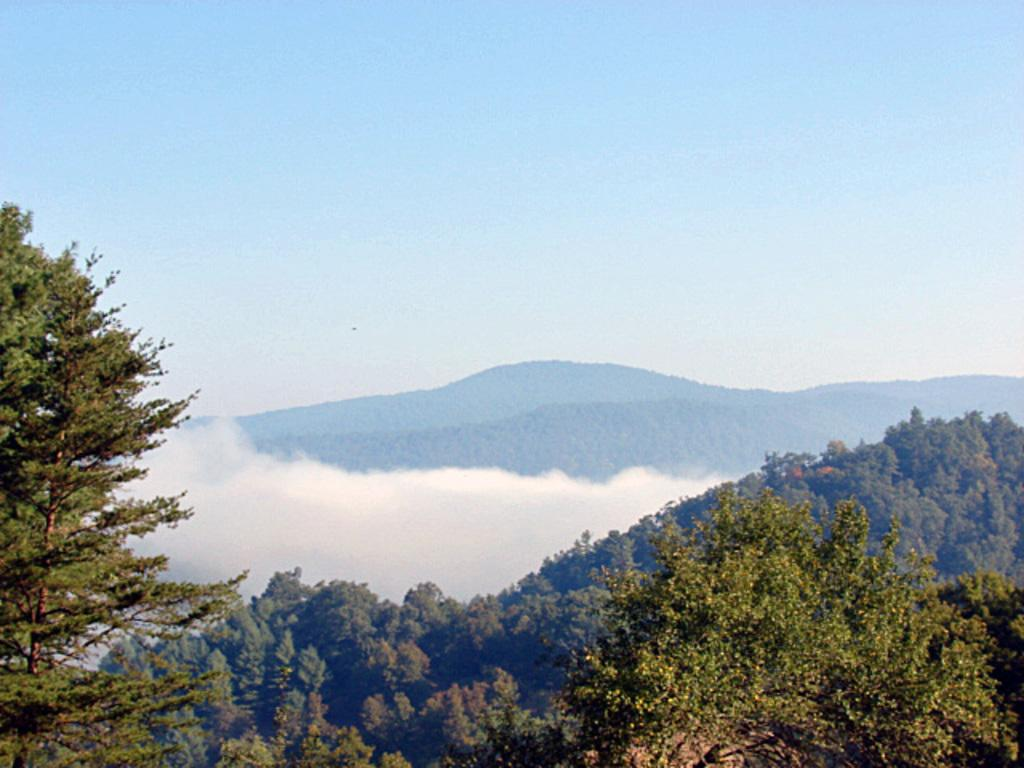What type of natural features can be seen in the image? There are trees and mountains in the image. What part of the natural environment is visible in the image? The sky is visible in the image. What type of pancake is being served on the table in the image? There is no table or pancake present in the image; it features trees, mountains, and the sky. Can you see a dog playing in the mountains in the image? There is no dog present in the image; it only features trees, mountains, and the sky. 